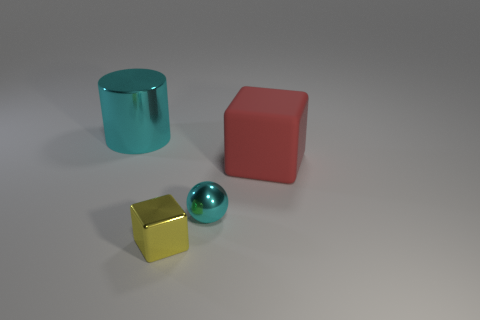Subtract all red cubes. How many cubes are left? 1 Add 3 yellow metal blocks. How many objects exist? 7 Subtract all cylinders. How many objects are left? 3 Subtract 1 balls. How many balls are left? 0 Subtract all cyan blocks. Subtract all brown cylinders. How many blocks are left? 2 Subtract all purple cylinders. How many blue balls are left? 0 Subtract all yellow cubes. Subtract all tiny metallic blocks. How many objects are left? 2 Add 4 metal cylinders. How many metal cylinders are left? 5 Add 2 tiny cyan things. How many tiny cyan things exist? 3 Subtract 0 red cylinders. How many objects are left? 4 